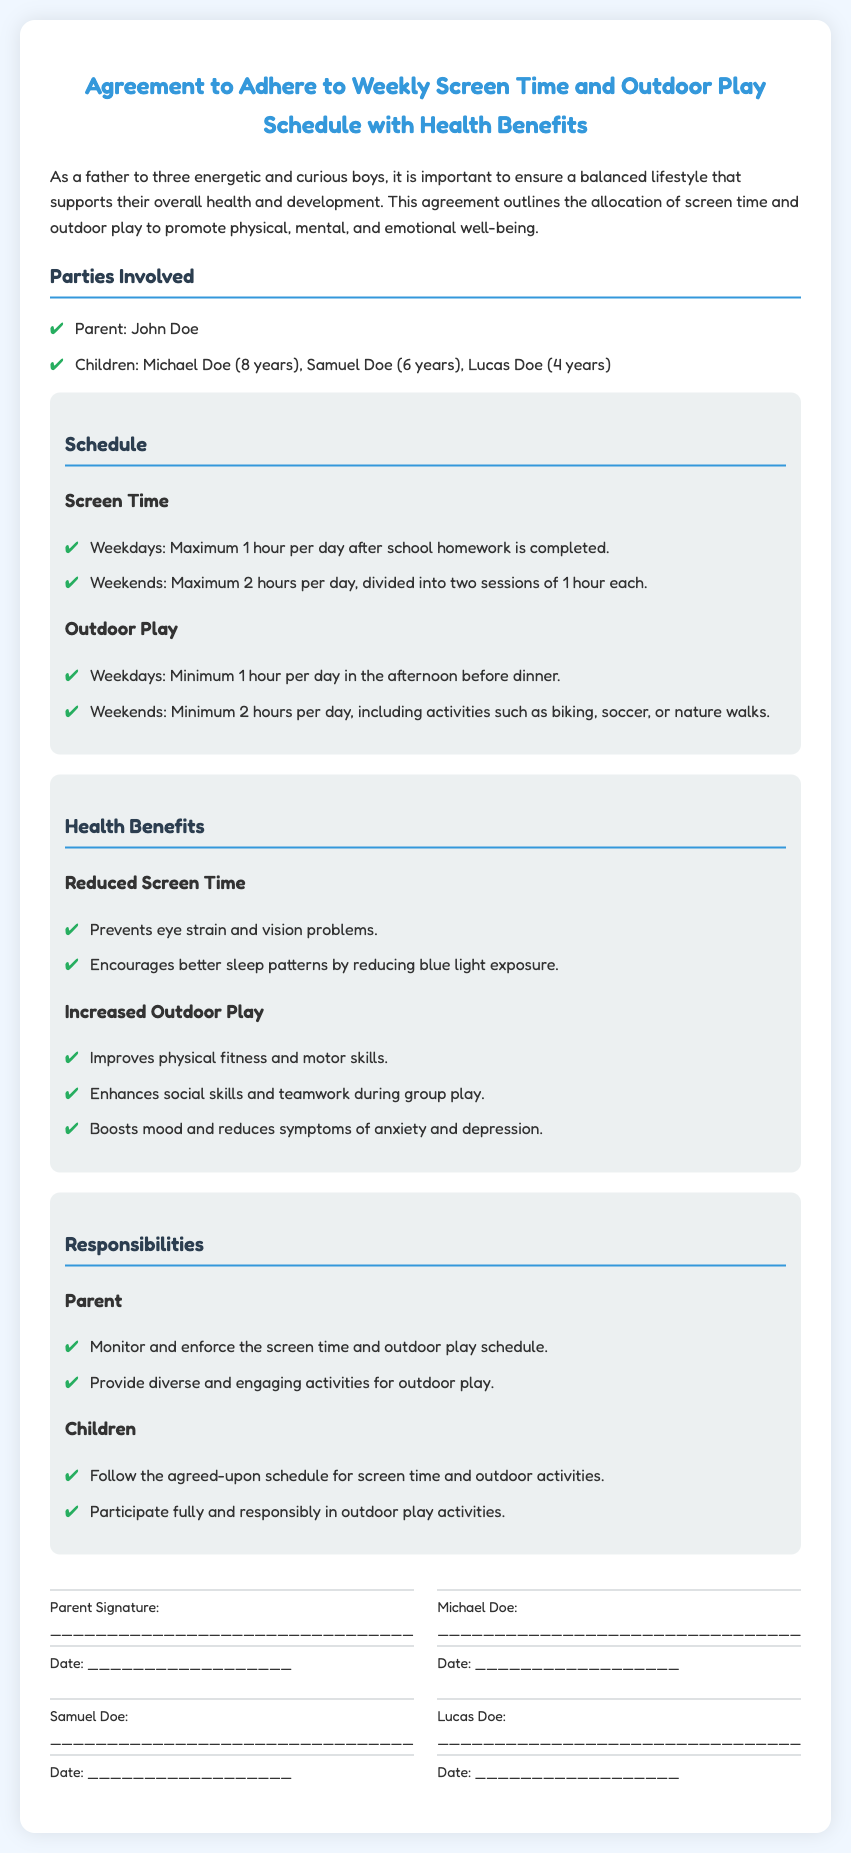What is the maximum screen time allowed on weekdays? The document states the maximum screen time on weekdays is 1 hour per day after school homework is completed.
Answer: 1 hour What activities are included in outdoor play on weekends? The document lists activities for outdoor play on weekends such as biking, soccer, or nature walks.
Answer: Biking, soccer, nature walks Who is responsible for monitoring the screen time and outdoor play schedule? The responsibilities section indicates that the parent is responsible for monitoring and enforcing the schedule.
Answer: Parent What is the age of Michael Doe? The document mentions that Michael Doe is 8 years old.
Answer: 8 years How many hours of outdoor play are required on weekdays? The document specifies that a minimum of 1 hour of outdoor play is required on weekdays.
Answer: 1 hour What is the benefit of reducing screen time? The benefits section states that reducing screen time prevents eye strain and vision problems.
Answer: Prevents eye strain and vision problems What document type is this? The title of the document indicates it is an Agreement to Adhere to a schedule related to screen time and outdoor play.
Answer: Agreement How many children are involved in this agreement? The document lists three children: Michael, Samuel, and Lucas.
Answer: Three children What is the date format for the signatures? The document indicates the date format for the signatures as "__________________" for each participant.
Answer: __________________ 